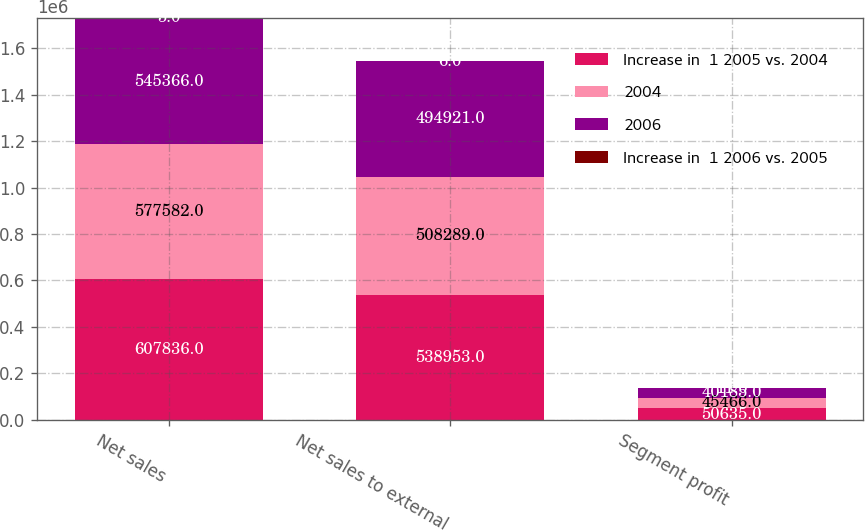Convert chart. <chart><loc_0><loc_0><loc_500><loc_500><stacked_bar_chart><ecel><fcel>Net sales<fcel>Net sales to external<fcel>Segment profit<nl><fcel>Increase in  1 2005 vs. 2004<fcel>607836<fcel>538953<fcel>50635<nl><fcel>2004<fcel>577582<fcel>508289<fcel>45466<nl><fcel>2006<fcel>545366<fcel>494921<fcel>40185<nl><fcel>Increase in  1 2006 vs. 2005<fcel>5<fcel>6<fcel>11<nl></chart> 